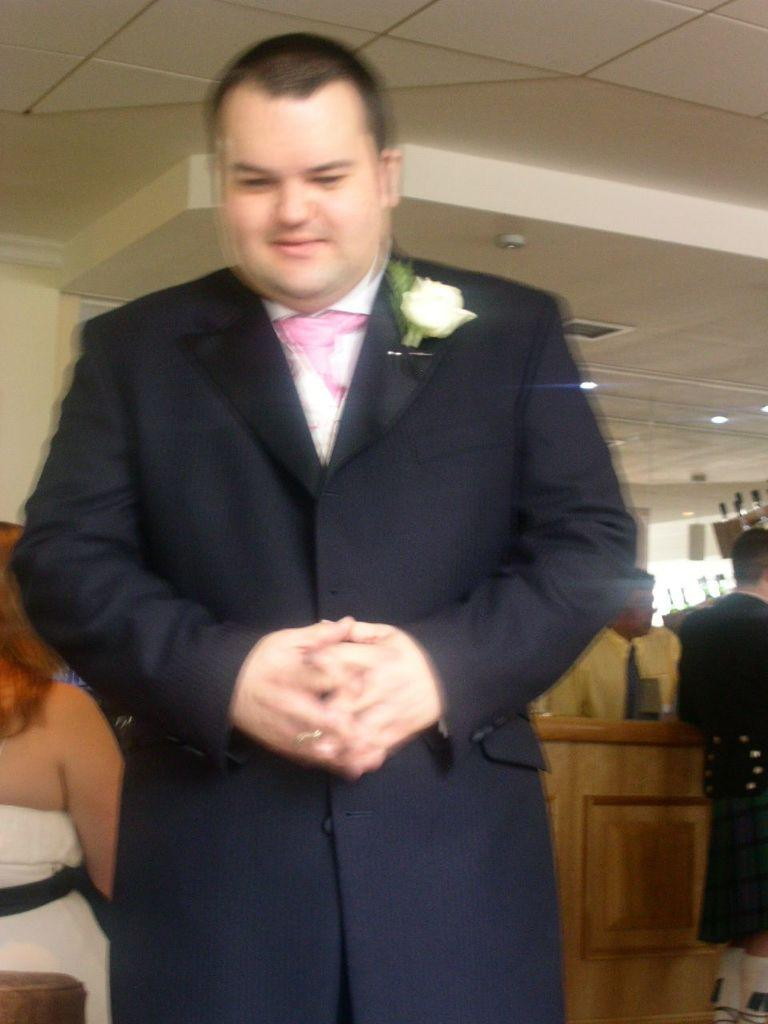What is the main subject of the image? There is a person in the image. Are there any other people in the image? Yes, there are other people behind the person. What type of furniture is present in the image? There is a wooden table in the image. What type of lighting is visible in the image? There are fall ceiling lights visible at the top of the image. What shape is the cup on the table in the image? There is no cup present on the table in the image. How many eggs are visible in the image? There are no eggs visible in the image. 